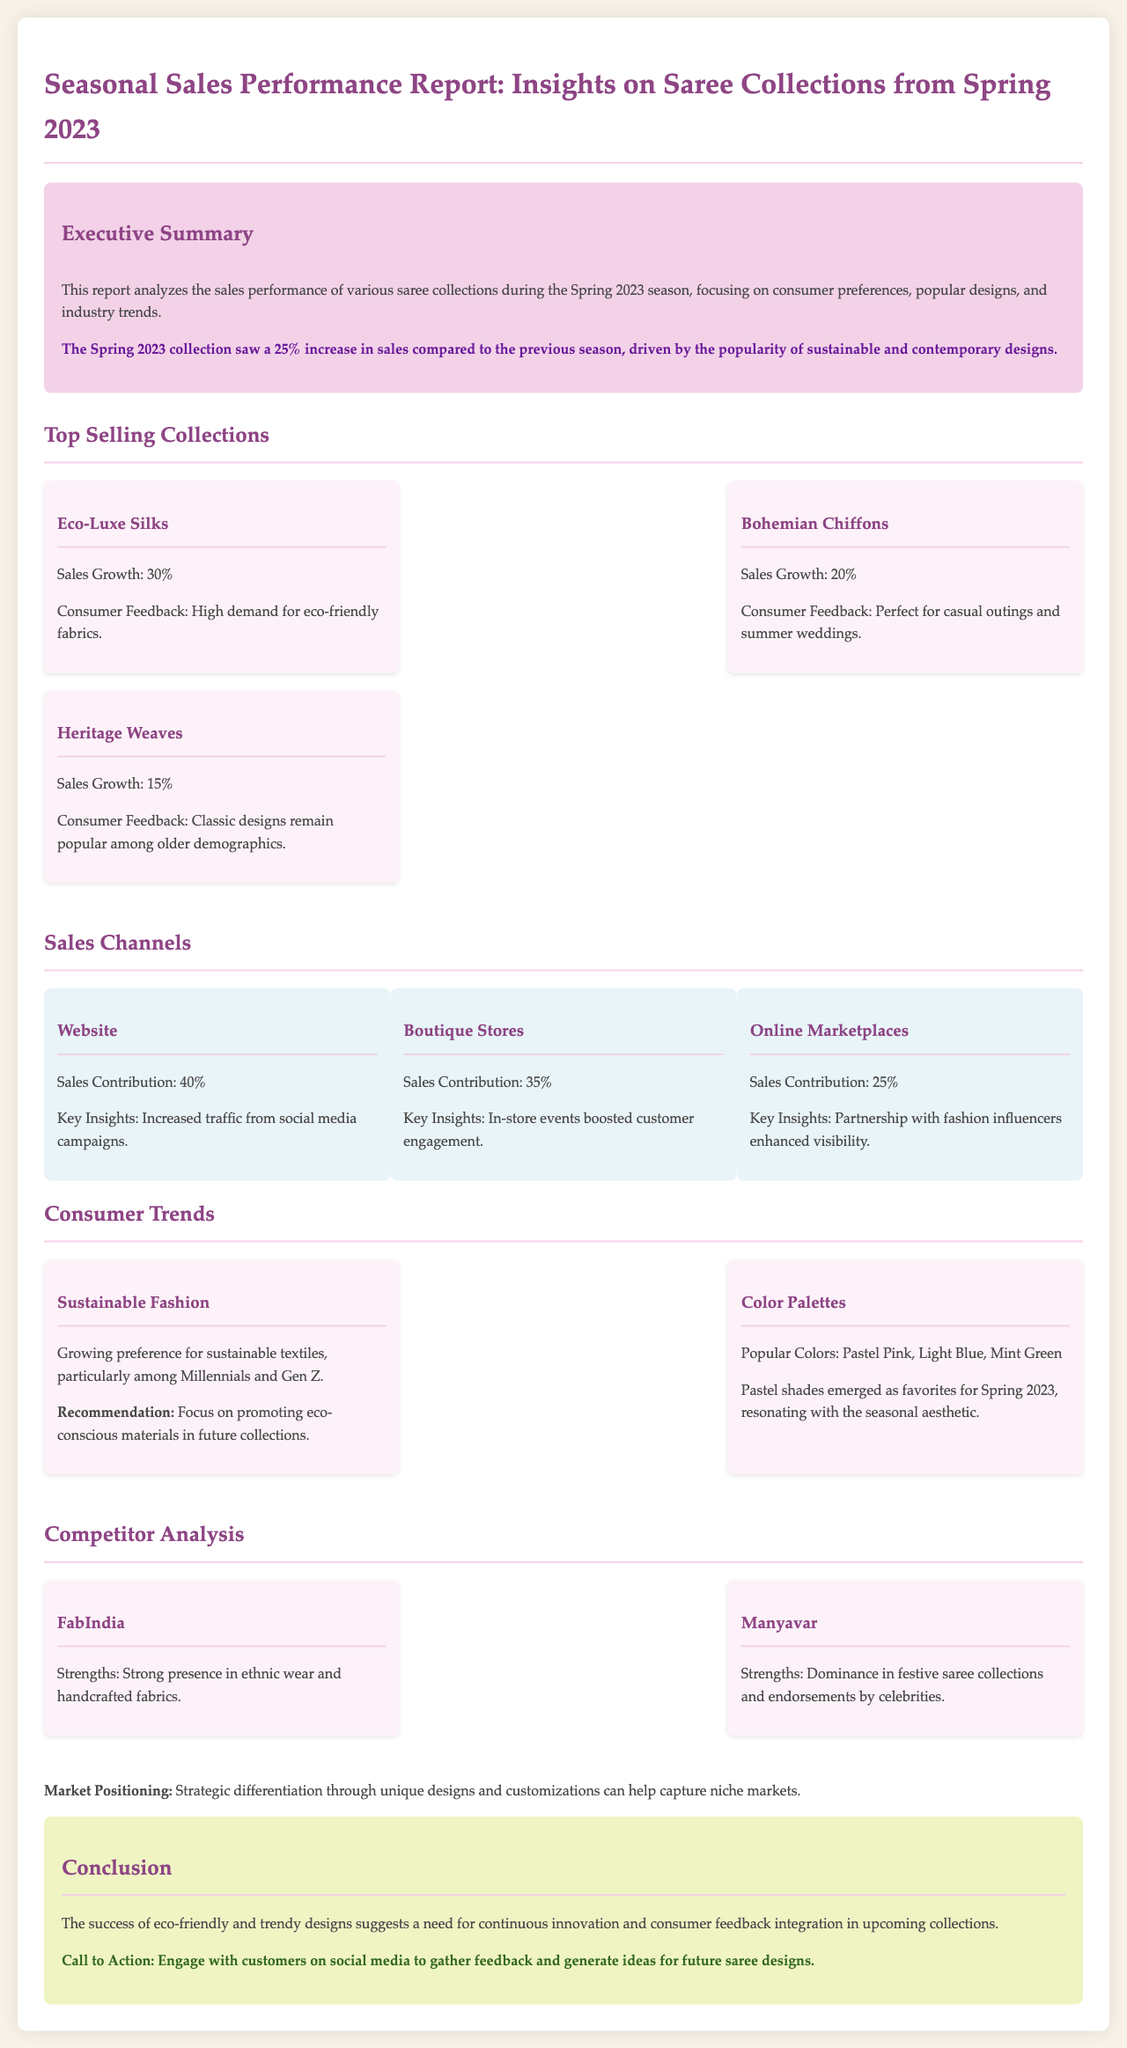What was the sales growth percentage for Eco-Luxe Silks? The document states that the sales growth for Eco-Luxe Silks was 30%.
Answer: 30% What is the most popular color palette for Spring 2023? The report indicates that popular colors included Pastel Pink, Light Blue, and Mint Green.
Answer: Pastel Pink, Light Blue, Mint Green Which selling channel contributed 40% to the sales? The text specifies that the website contributed 40% to the overall sales.
Answer: Website What is the key insight for online marketplaces? The report mentions that a partnership with fashion influencers enhanced visibility for online marketplaces.
Answer: Partnership with fashion influencers What is the recommended focus for future collections? It is suggested to promote eco-conscious materials in upcoming collections based on consumer trends.
Answer: Promote eco-conscious materials Which saree collection had the highest sales growth? Eco-Luxe Silks had the highest sales growth at 30%.
Answer: Eco-Luxe Silks What demographic is showing a growing preference for sustainable textiles? The report notes that Millennials and Gen Z are increasingly favoring sustainable textiles.
Answer: Millennials and Gen Z What percentage of sales came from boutique stores? The document mentions that boutique stores contributed 35% to the sales.
Answer: 35% Who are the two main competitors mentioned in the report? The key competitors listed are FabIndia and Manyavar.
Answer: FabIndia, Manyavar 